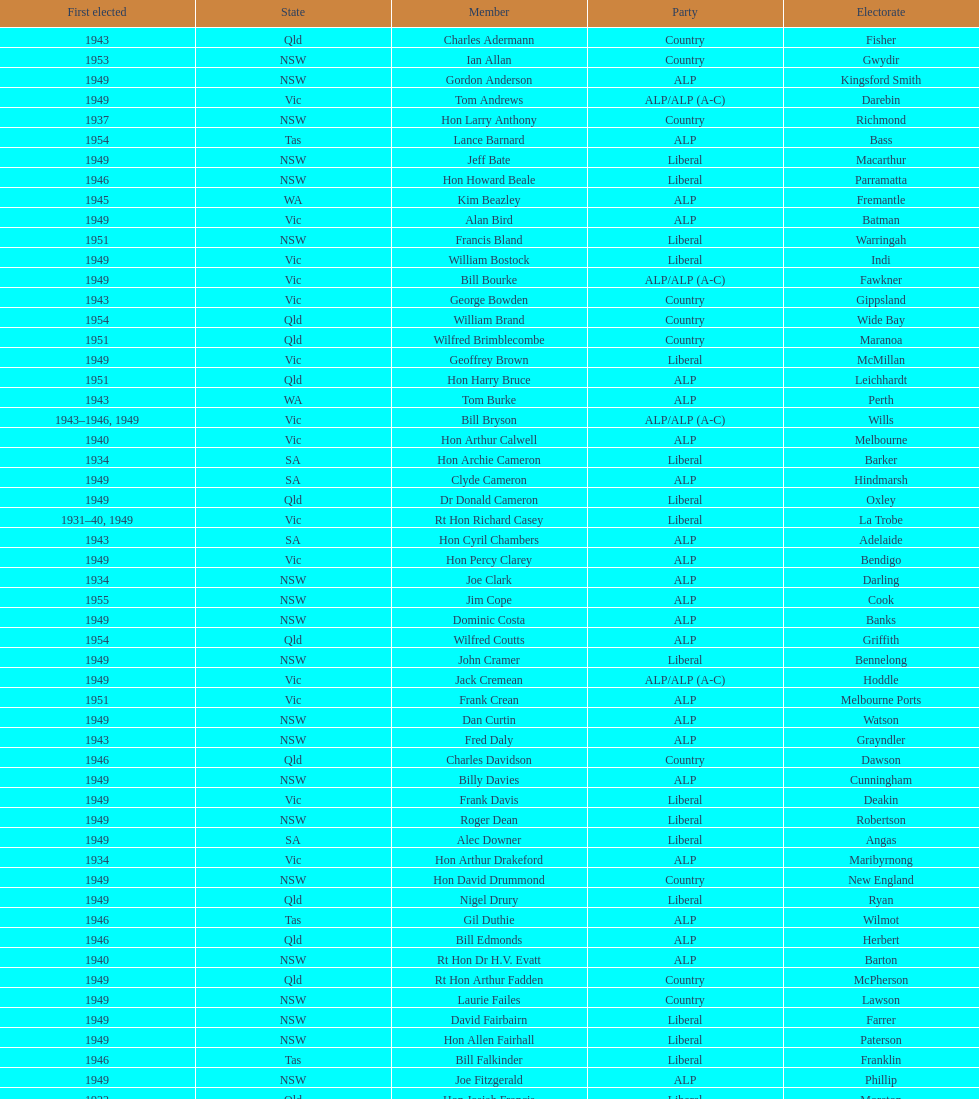After tom burke was elected, what was the next year where another tom would be elected? 1937. 